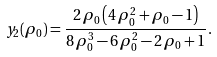Convert formula to latex. <formula><loc_0><loc_0><loc_500><loc_500>y _ { 2 } ( \rho _ { 0 } ) = \frac { 2 \, \rho _ { 0 } \left ( 4 \, \rho _ { 0 } ^ { 2 } + \rho _ { 0 } - 1 \right ) } { 8 \, \rho _ { 0 } ^ { 3 } - 6 \, \rho _ { 0 } ^ { 2 } - 2 \, \rho _ { 0 } + 1 } .</formula> 